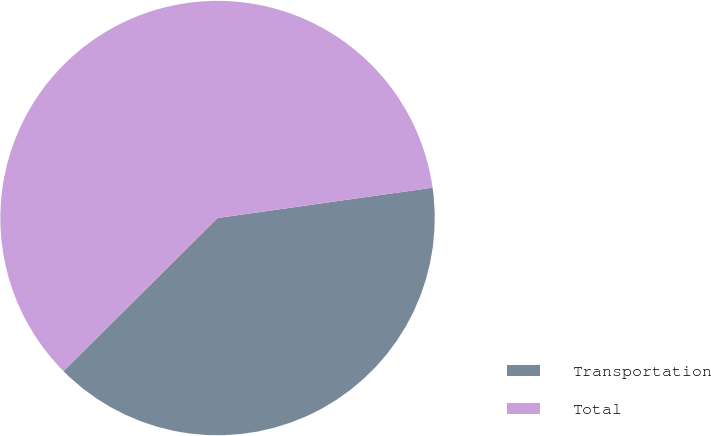Convert chart to OTSL. <chart><loc_0><loc_0><loc_500><loc_500><pie_chart><fcel>Transportation<fcel>Total<nl><fcel>39.78%<fcel>60.22%<nl></chart> 